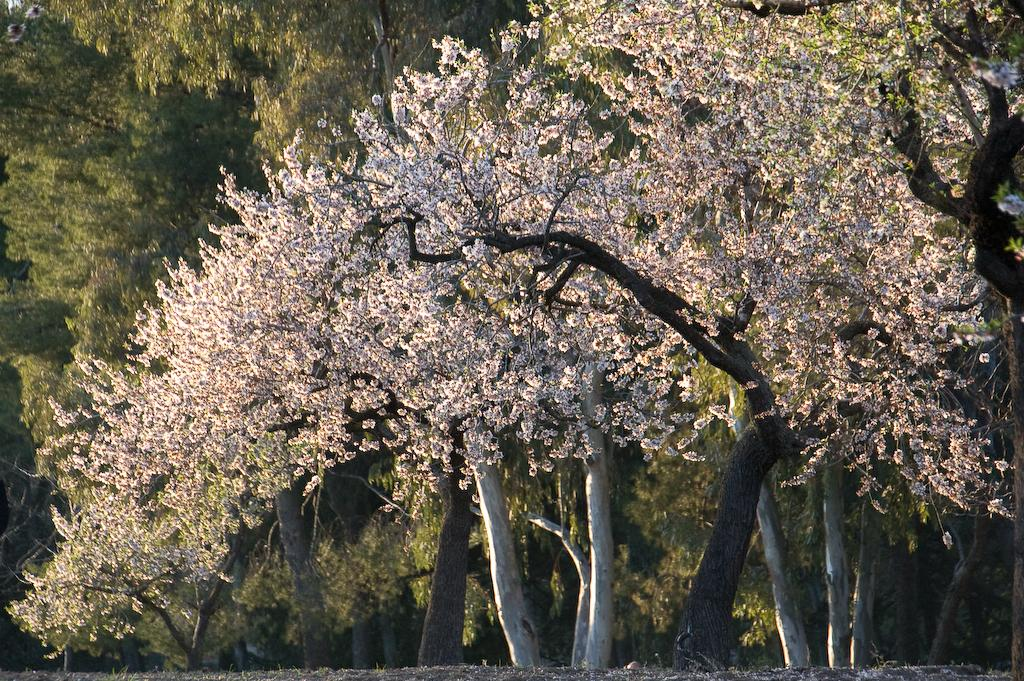What type of vegetation can be seen in the image? There are trees in the image. What else can be seen on the ground in the image? There are objects on the ground in the image. What letter is being compared to the yam in the image? There is no letter or yam present in the image, so no comparison can be made. 